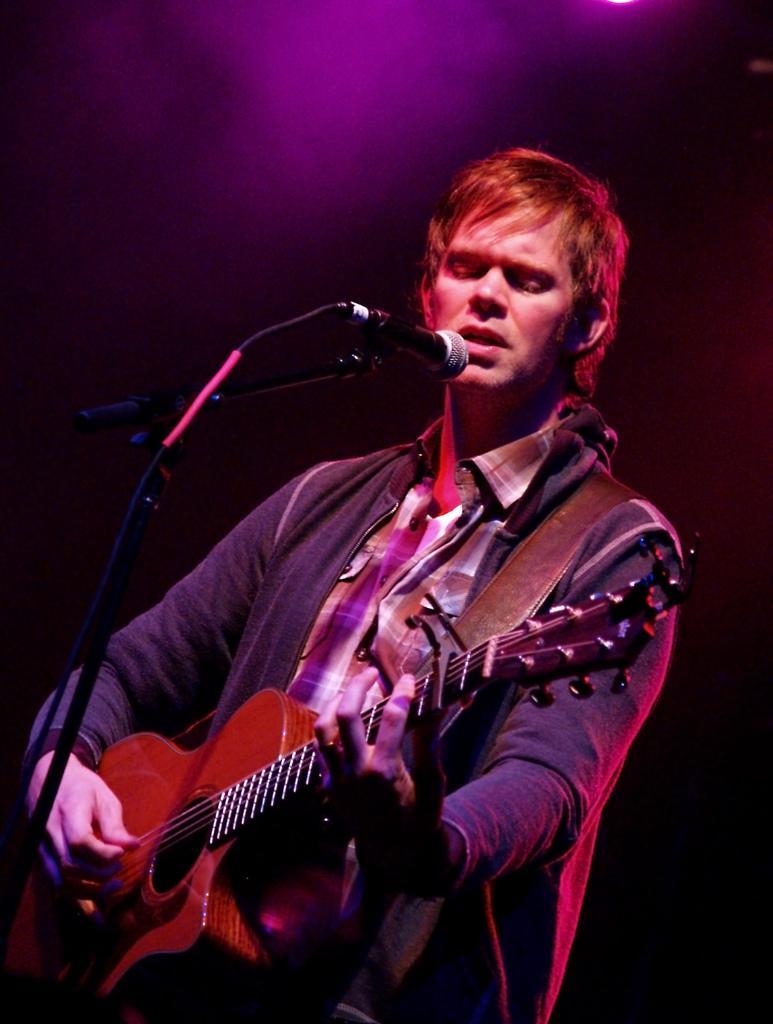Please provide a concise description of this image. In the image there is a man standing and holding a guitar and playing it in front of a microphone and opened his mouth for singing.. 